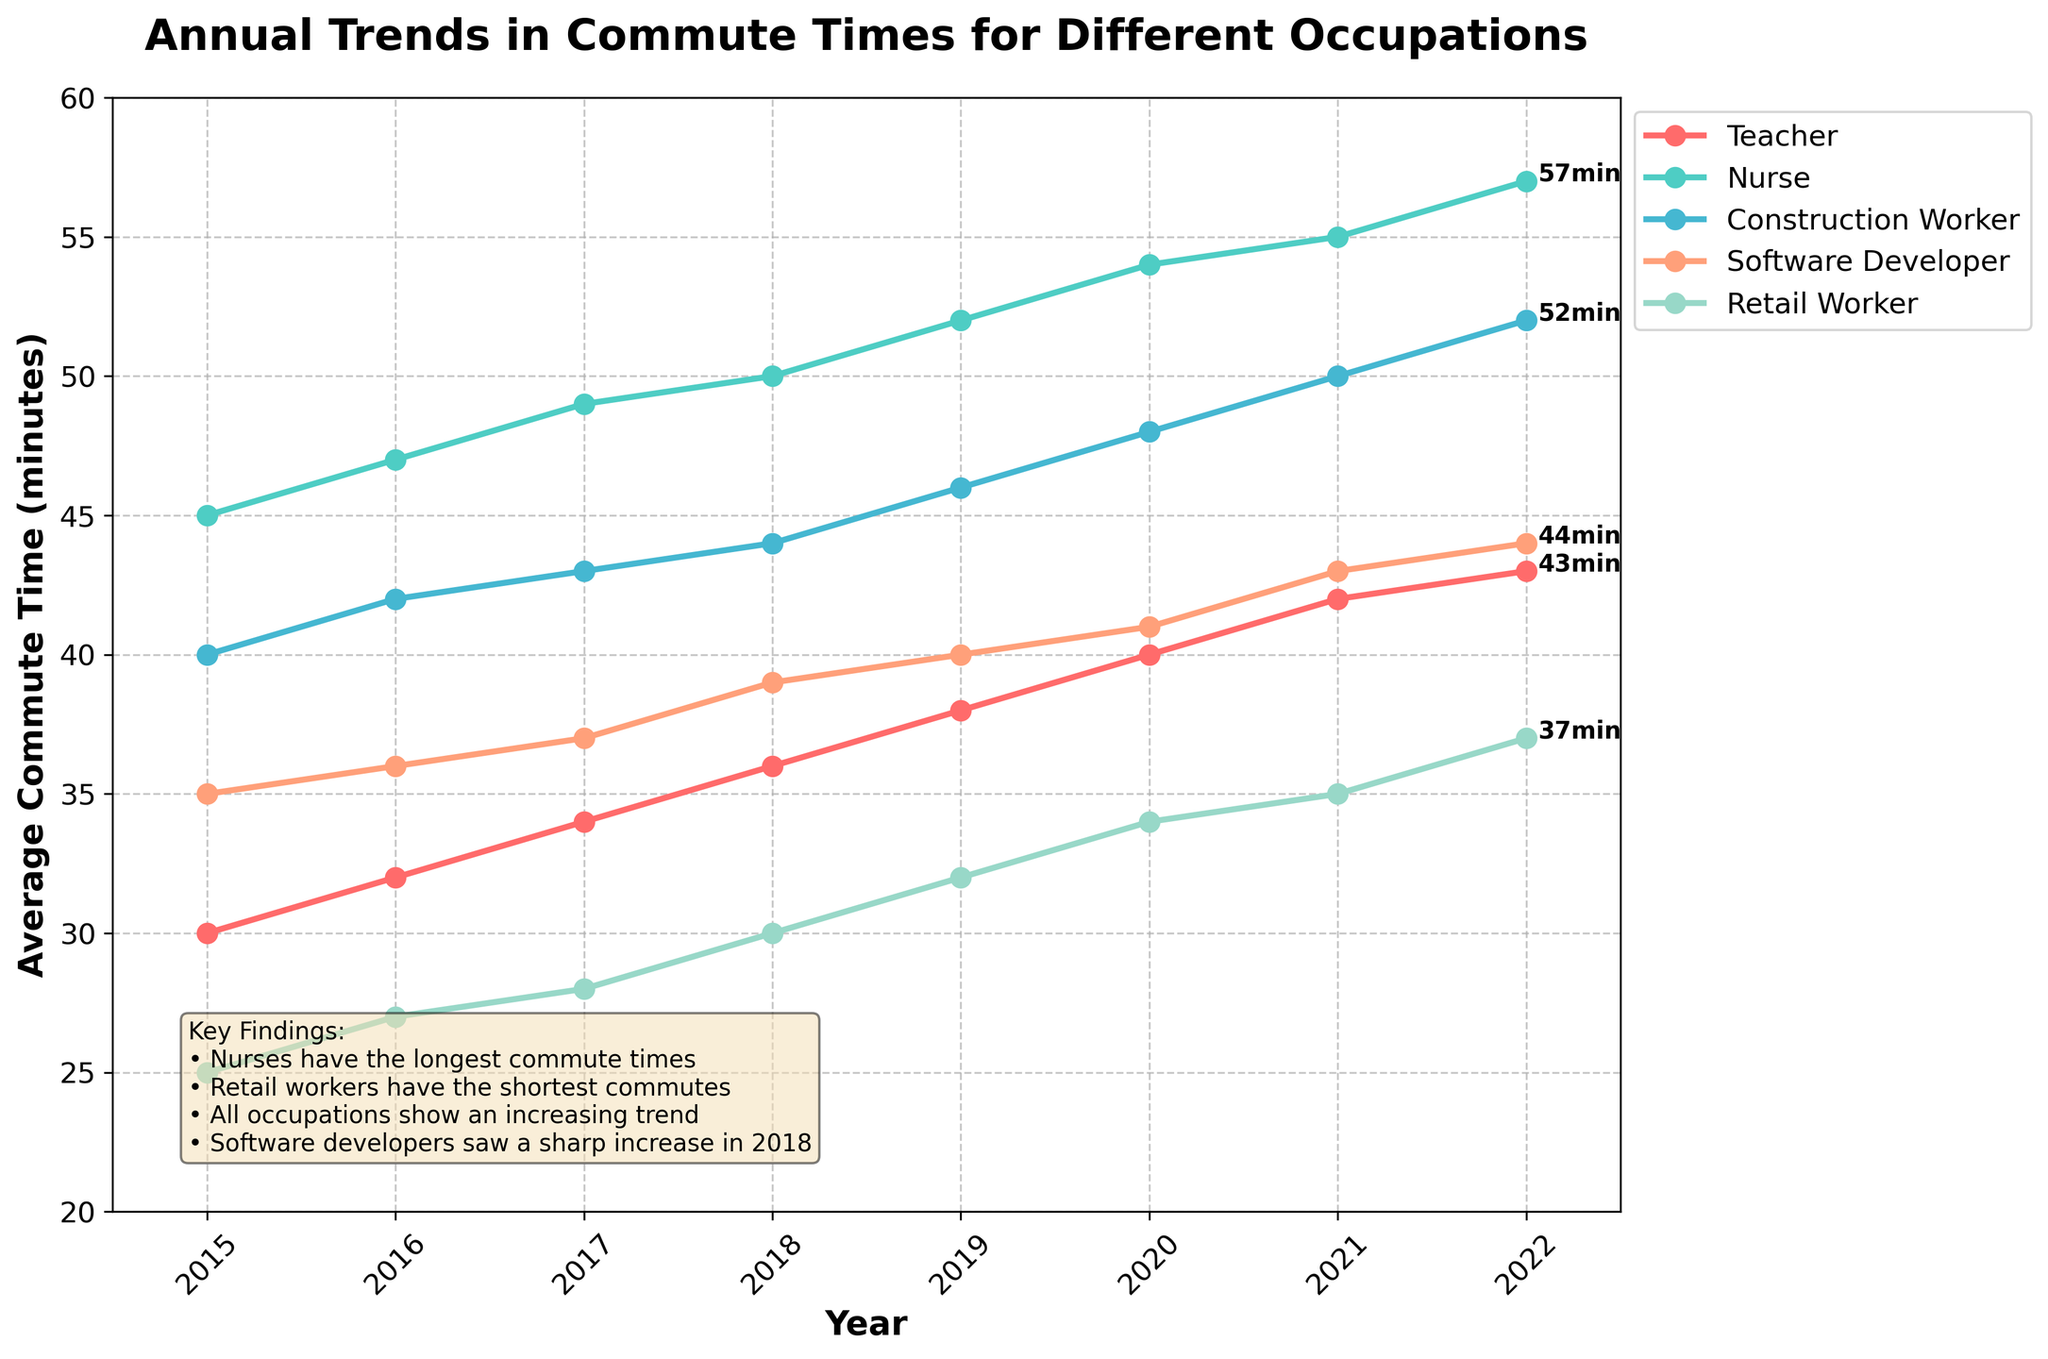What's the title of the figure? The title is displayed at the top of the plot, clearly indicating what the figure represents.
Answer: Annual Trends in Commute Times for Different Occupations How many occupations are shown in the figure? The figure includes lines with different colors and labels in the legend for each occupation. By counting the unique labels, we determine the number of occupations.
Answer: 5 Which occupation had the longest average commute time in 2022? The plot lines end at 2022 with different commute times annotated. By looking at the highest value, we find the occupation with the longest average commute time.
Answer: Nurse What is the average commute time difference between Teachers and Retail Workers in 2020? To find the difference, locate the points for Teachers and Retail Workers in 2020 and subtract the commute times: 40 minutes (Teacher) - 34 minutes (Retail Worker) = 6 minutes.
Answer: 6 minutes Did any occupation see a decrease in average commute time from 2015 to 2022? By checking the trend lines from 2015 to 2022 for each occupation, we see that all lines are increasing, indicating no decrease.
Answer: No Which occupation saw the sharpest increase in commute time in 2018? By examining the slope of the lines in 2018, we see the sharpest increase in the Software Developer's line.
Answer: Software Developer What was the average commute time for Construction Workers in 2017? Locate the data point for Construction Workers in 2017 on the plot.
Answer: 43 minutes In which year did Retail Workers surpass 30 minutes of average commute time for the first time? Follow the Retail Workers' line until it crosses above the 30-minute mark and note the year.
Answer: 2018 How much did the average commute time for Teachers increase from 2015 to 2022? Subtract the 2015 value from the 2022 value for Teachers: 43 minutes (2022) - 30 minutes (2015) = 13 minutes.
Answer: 13 minutes Between 2019 and 2020, which occupation had the smallest increase in average commute time? Check the slope for each occupation between these years and identify the one with the smallest change.
Answer: Software Developer 